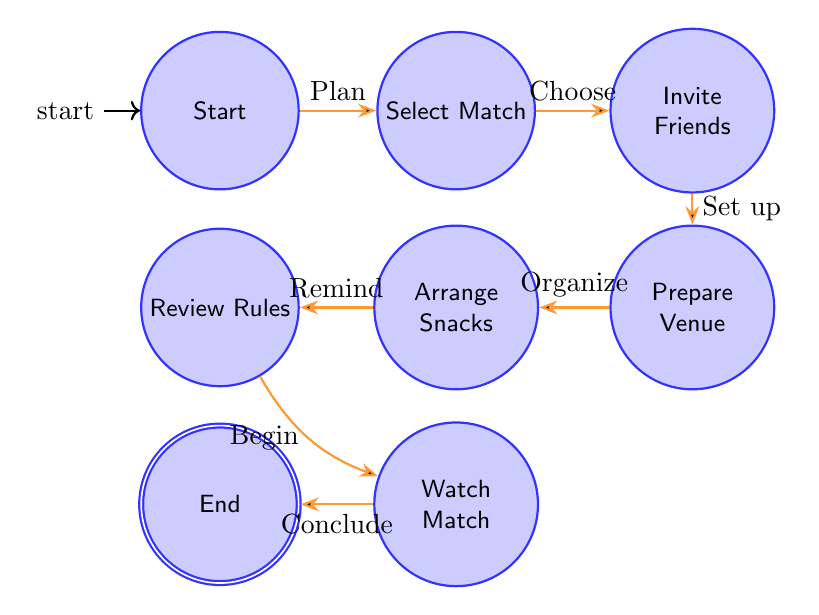What is the starting node of this diagram? The starting node, as indicated in the diagram, is labeled "Start". This is usually the initial point from which the flow begins.
Answer: Start How many nodes are there in total? To find the total number of nodes, you can count each one present in the diagram. Upon counting, there are 8 nodes listed.
Answer: 8 What is the node that follows "Select Match"? According to the flow of the diagram, the node that immediately follows "Select Match" is "Invite Friends". This node is directly connected to "Select Match".
Answer: Invite Friends What happens after "Watch Match"? The node that occurs after "Watch Match" is labeled "End". This represents the conclusion of the party planning process.
Answer: End Which node is connected to "Arrange Snacks and Drinks"? The node that is directly connected to "Arrange Snacks and Drinks" is "Review Rules", indicating the logical progression in the flow of the party planning.
Answer: Review Rules What is the last action before "Watch Match"? The last action before progressing to "Watch Match" is "Review Rules". This means that all attendees are reminded of the rules before enjoying the match.
Answer: Review Rules How many transitions are there in the diagram? The number of transitions can be counted by identifying each directed edge connecting the nodes. There are 7 transitions in total.
Answer: 7 What does the node "Prepare Venue" signify? "Prepare Venue" signifies the action of setting up and organizing the viewing area, ensuring it is suitable for the match. It is a key preparation step in the party planning.
Answer: Prepare Venue Which node represents the action of inviting friends? The node labeled "Invite Friends" represents the action of sending invites to fellow football enthusiasts for the viewing party.
Answer: Invite Friends 